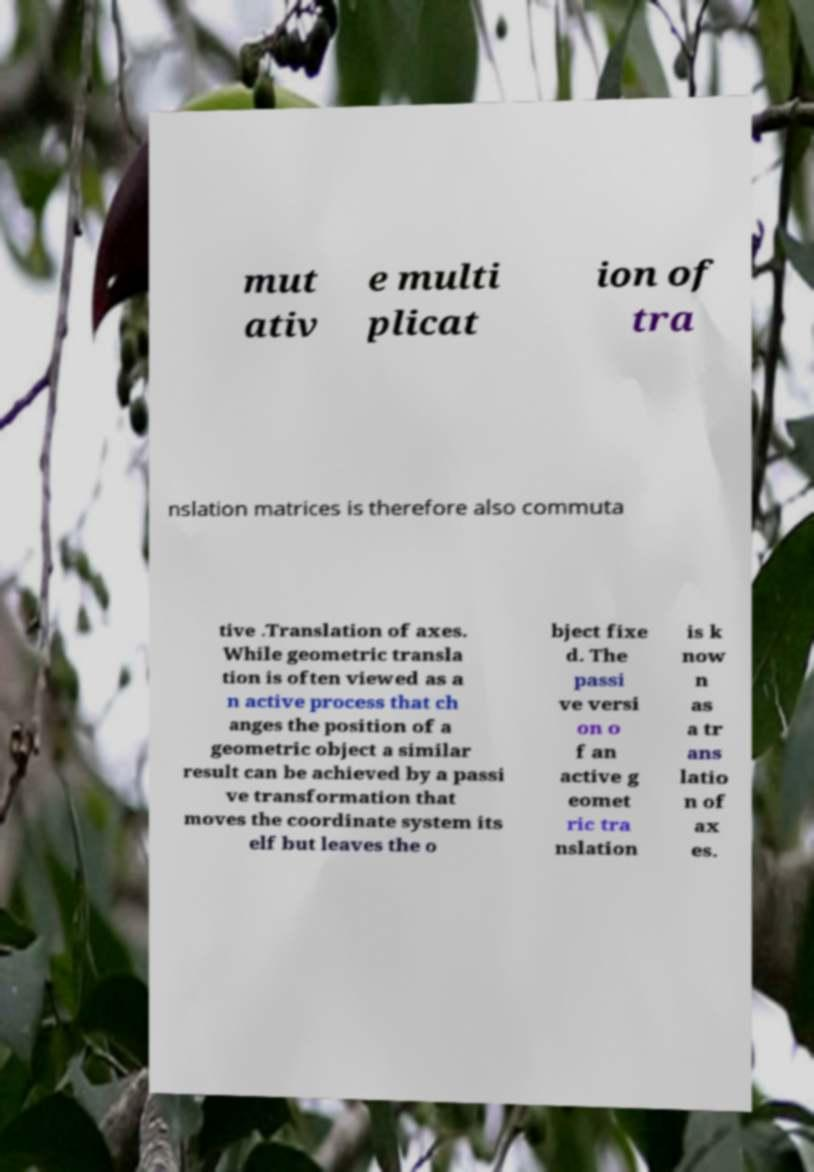What messages or text are displayed in this image? I need them in a readable, typed format. mut ativ e multi plicat ion of tra nslation matrices is therefore also commuta tive .Translation of axes. While geometric transla tion is often viewed as a n active process that ch anges the position of a geometric object a similar result can be achieved by a passi ve transformation that moves the coordinate system its elf but leaves the o bject fixe d. The passi ve versi on o f an active g eomet ric tra nslation is k now n as a tr ans latio n of ax es. 